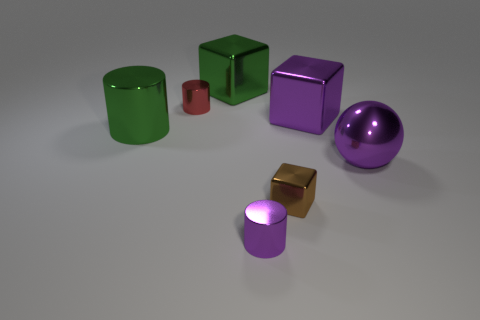What number of tiny metallic cylinders are behind the metallic sphere and on the right side of the small red shiny object?
Your answer should be very brief. 0. What is the shape of the purple metal object that is the same size as the purple metal cube?
Provide a short and direct response. Sphere. Is there a purple cube in front of the big shiny block that is in front of the large green metal thing that is behind the large green cylinder?
Give a very brief answer. No. Does the metallic sphere have the same color as the block that is on the right side of the small brown cube?
Your answer should be very brief. Yes. How many shiny cylinders are the same color as the small block?
Provide a short and direct response. 0. There is a shiny thing to the right of the cube on the right side of the brown object; what is its size?
Ensure brevity in your answer.  Large. How many objects are either small cylinders that are in front of the big shiny cylinder or large purple shiny spheres?
Offer a very short reply. 2. Are there any green objects of the same size as the ball?
Make the answer very short. Yes. Are there any purple cylinders that are behind the large green thing in front of the large purple cube?
Your answer should be compact. No. What number of cylinders are large shiny things or small purple metallic objects?
Ensure brevity in your answer.  2. 